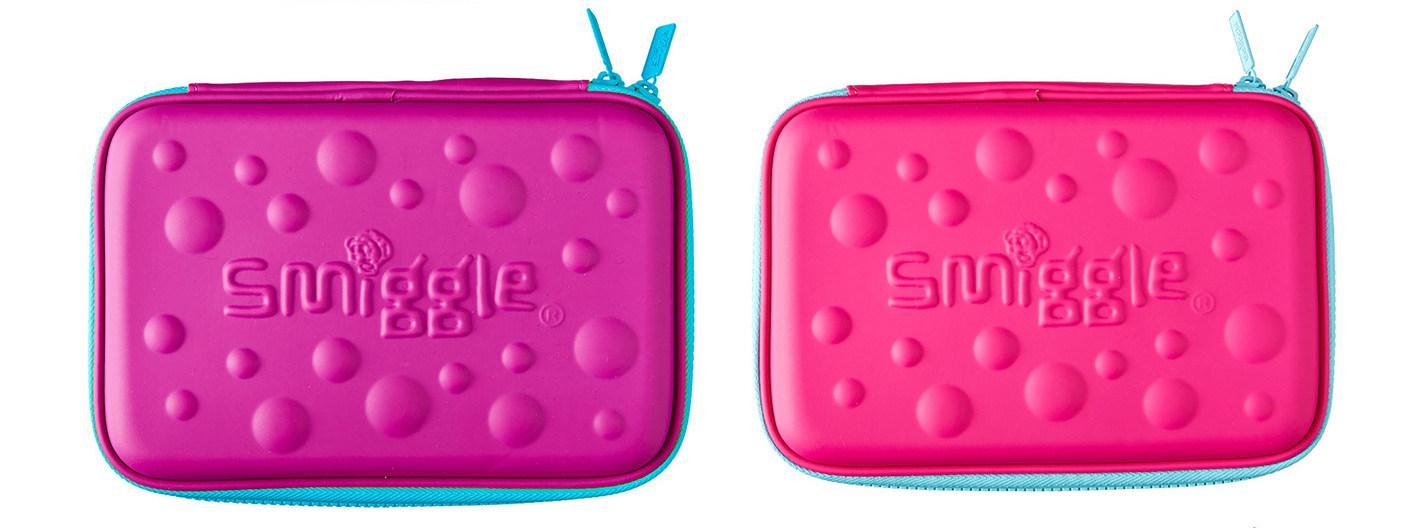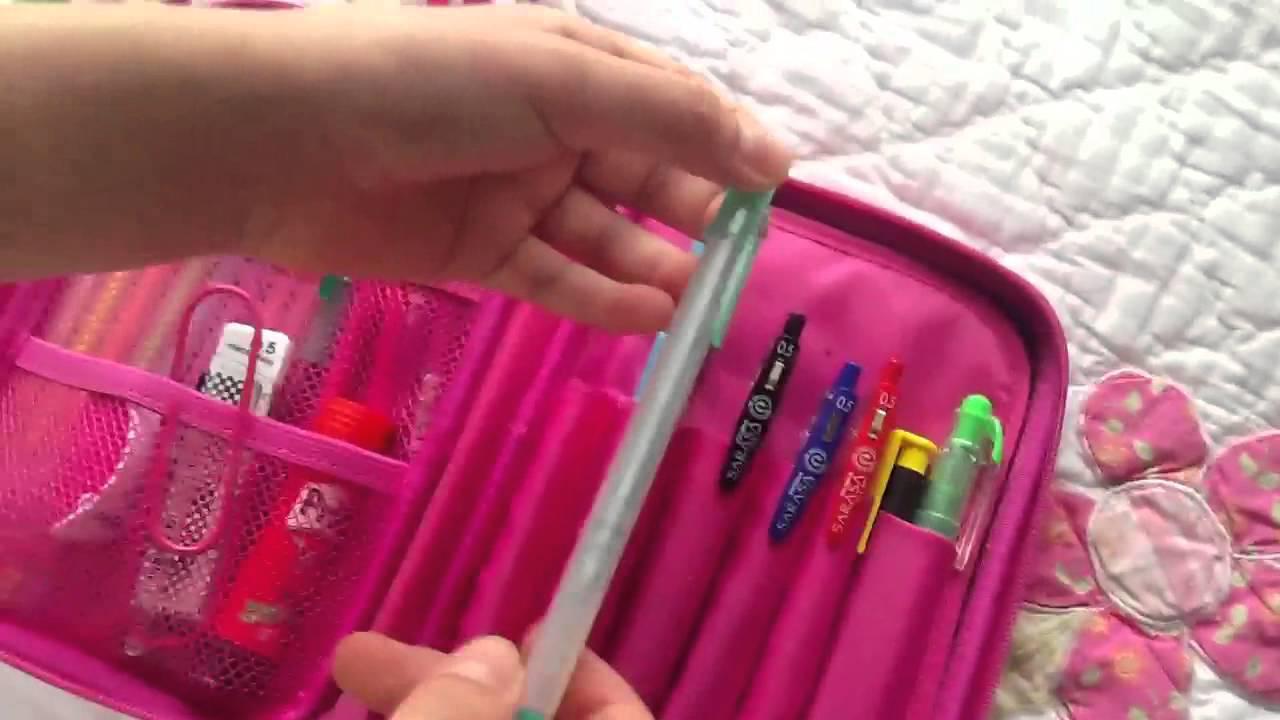The first image is the image on the left, the second image is the image on the right. Considering the images on both sides, is "One of the containers contains a pair of scissors." valid? Answer yes or no. No. The first image is the image on the left, the second image is the image on the right. For the images displayed, is the sentence "A pair of scissors is in the pencil pouch next to a pencil." factually correct? Answer yes or no. No. 